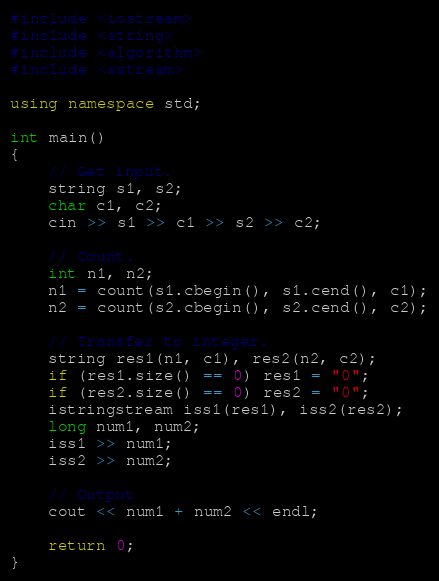Convert code to text. <code><loc_0><loc_0><loc_500><loc_500><_C++_>#include <iostream>
#include <string>
#include <algorithm>
#include <sstream>

using namespace std;

int main()
{
	// Get input.
	string s1, s2;
	char c1, c2;
	cin >> s1 >> c1 >> s2 >> c2;

	// Count.
	int n1, n2;
	n1 = count(s1.cbegin(), s1.cend(), c1);
	n2 = count(s2.cbegin(), s2.cend(), c2);

	// Transfer to integer.
	string res1(n1, c1), res2(n2, c2);
	if (res1.size() == 0) res1 = "0";
	if (res2.size() == 0) res2 = "0";
	istringstream iss1(res1), iss2(res2);
	long num1, num2;
	iss1 >> num1;
	iss2 >> num2;

	// Output
	cout << num1 + num2 << endl;

	return 0;
}</code> 